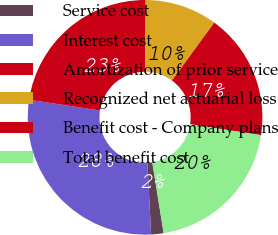Convert chart. <chart><loc_0><loc_0><loc_500><loc_500><pie_chart><fcel>Service cost<fcel>Interest cost<fcel>Amortization of prior service<fcel>Recognized net actuarial loss<fcel>Benefit cost - Company plans<fcel>Total benefit cost<nl><fcel>1.71%<fcel>28.21%<fcel>22.68%<fcel>9.97%<fcel>17.38%<fcel>20.03%<nl></chart> 